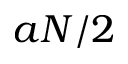<formula> <loc_0><loc_0><loc_500><loc_500>a N / 2</formula> 